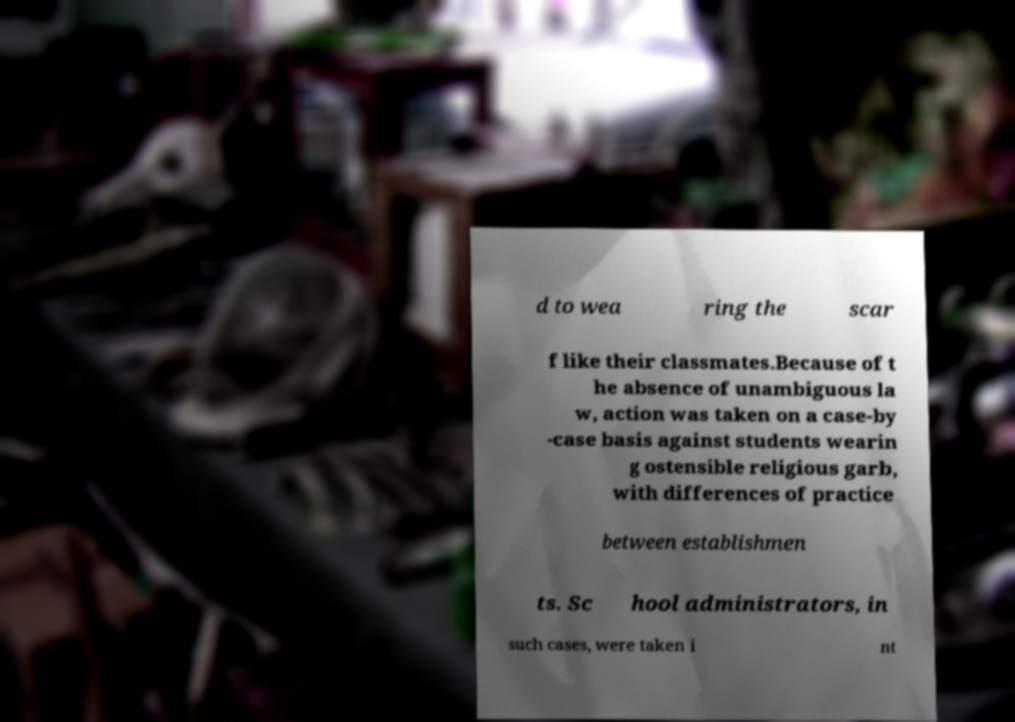Can you read and provide the text displayed in the image?This photo seems to have some interesting text. Can you extract and type it out for me? d to wea ring the scar f like their classmates.Because of t he absence of unambiguous la w, action was taken on a case-by -case basis against students wearin g ostensible religious garb, with differences of practice between establishmen ts. Sc hool administrators, in such cases, were taken i nt 